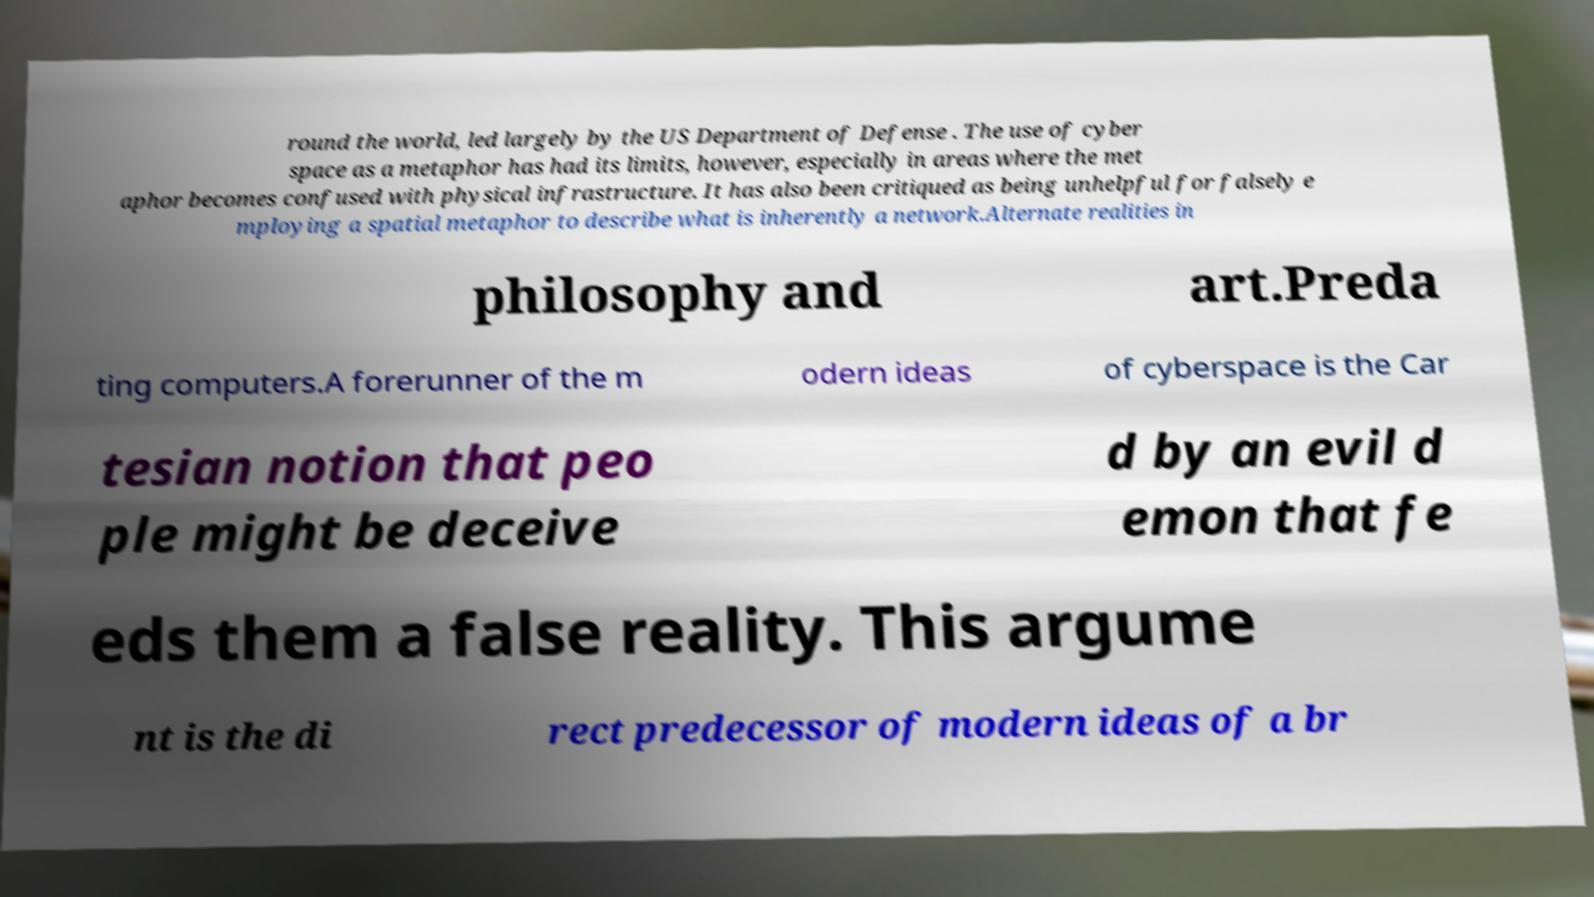Could you assist in decoding the text presented in this image and type it out clearly? round the world, led largely by the US Department of Defense . The use of cyber space as a metaphor has had its limits, however, especially in areas where the met aphor becomes confused with physical infrastructure. It has also been critiqued as being unhelpful for falsely e mploying a spatial metaphor to describe what is inherently a network.Alternate realities in philosophy and art.Preda ting computers.A forerunner of the m odern ideas of cyberspace is the Car tesian notion that peo ple might be deceive d by an evil d emon that fe eds them a false reality. This argume nt is the di rect predecessor of modern ideas of a br 